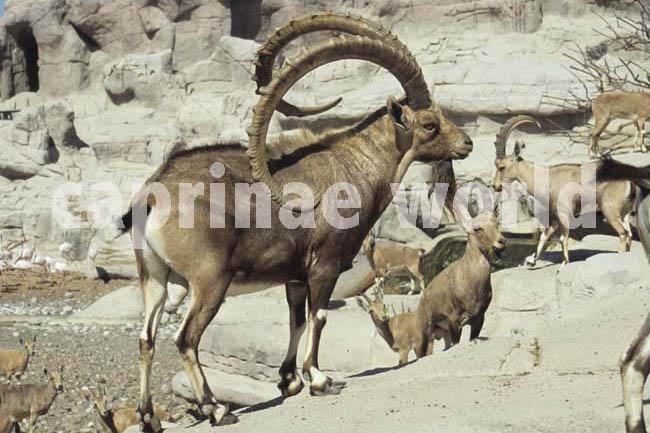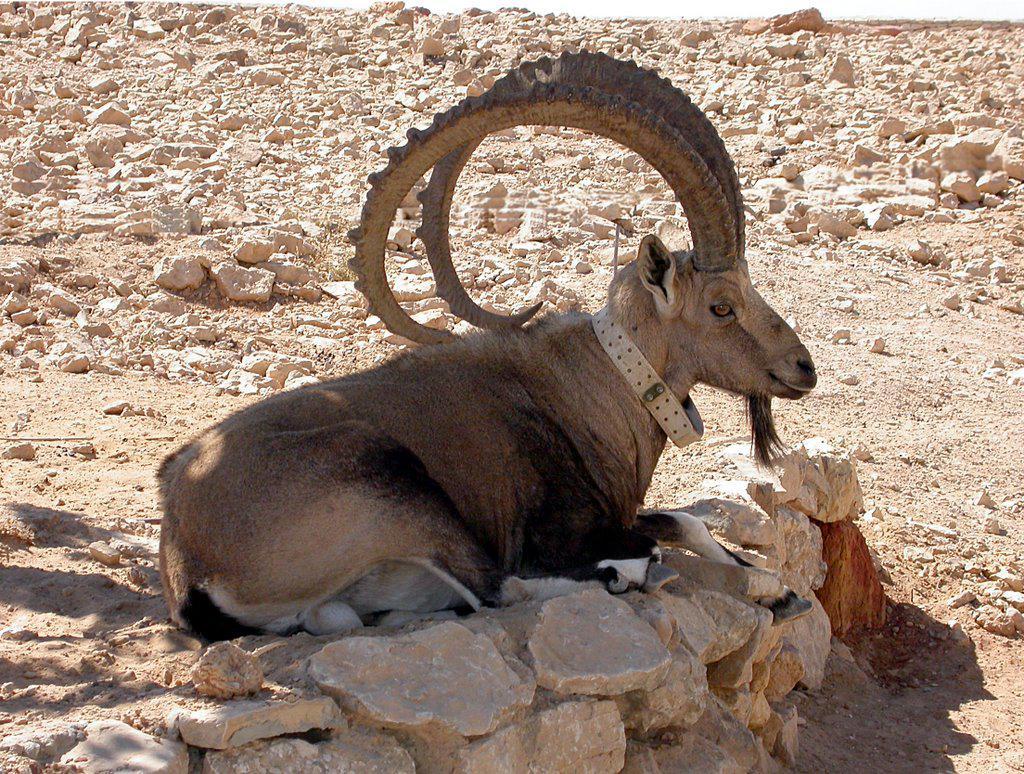The first image is the image on the left, the second image is the image on the right. Given the left and right images, does the statement "At least one big horn sheep is looking down over the edge of a tall cliff." hold true? Answer yes or no. No. 